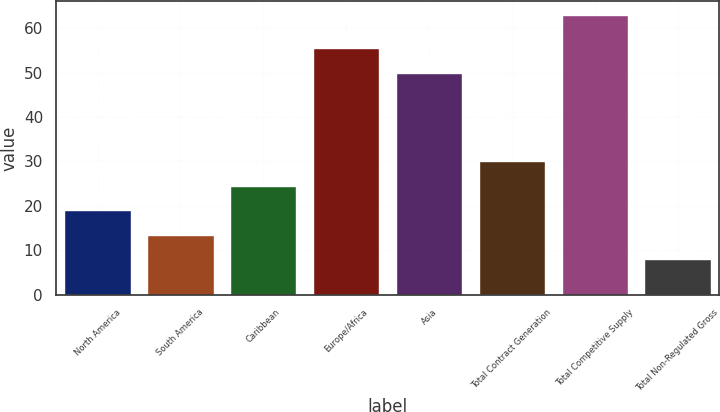Convert chart. <chart><loc_0><loc_0><loc_500><loc_500><bar_chart><fcel>North America<fcel>South America<fcel>Caribbean<fcel>Europe/Africa<fcel>Asia<fcel>Total Contract Generation<fcel>Total Competitive Supply<fcel>Total Non-Regulated Gross<nl><fcel>19<fcel>13.5<fcel>24.5<fcel>55.5<fcel>50<fcel>30<fcel>63<fcel>8<nl></chart> 